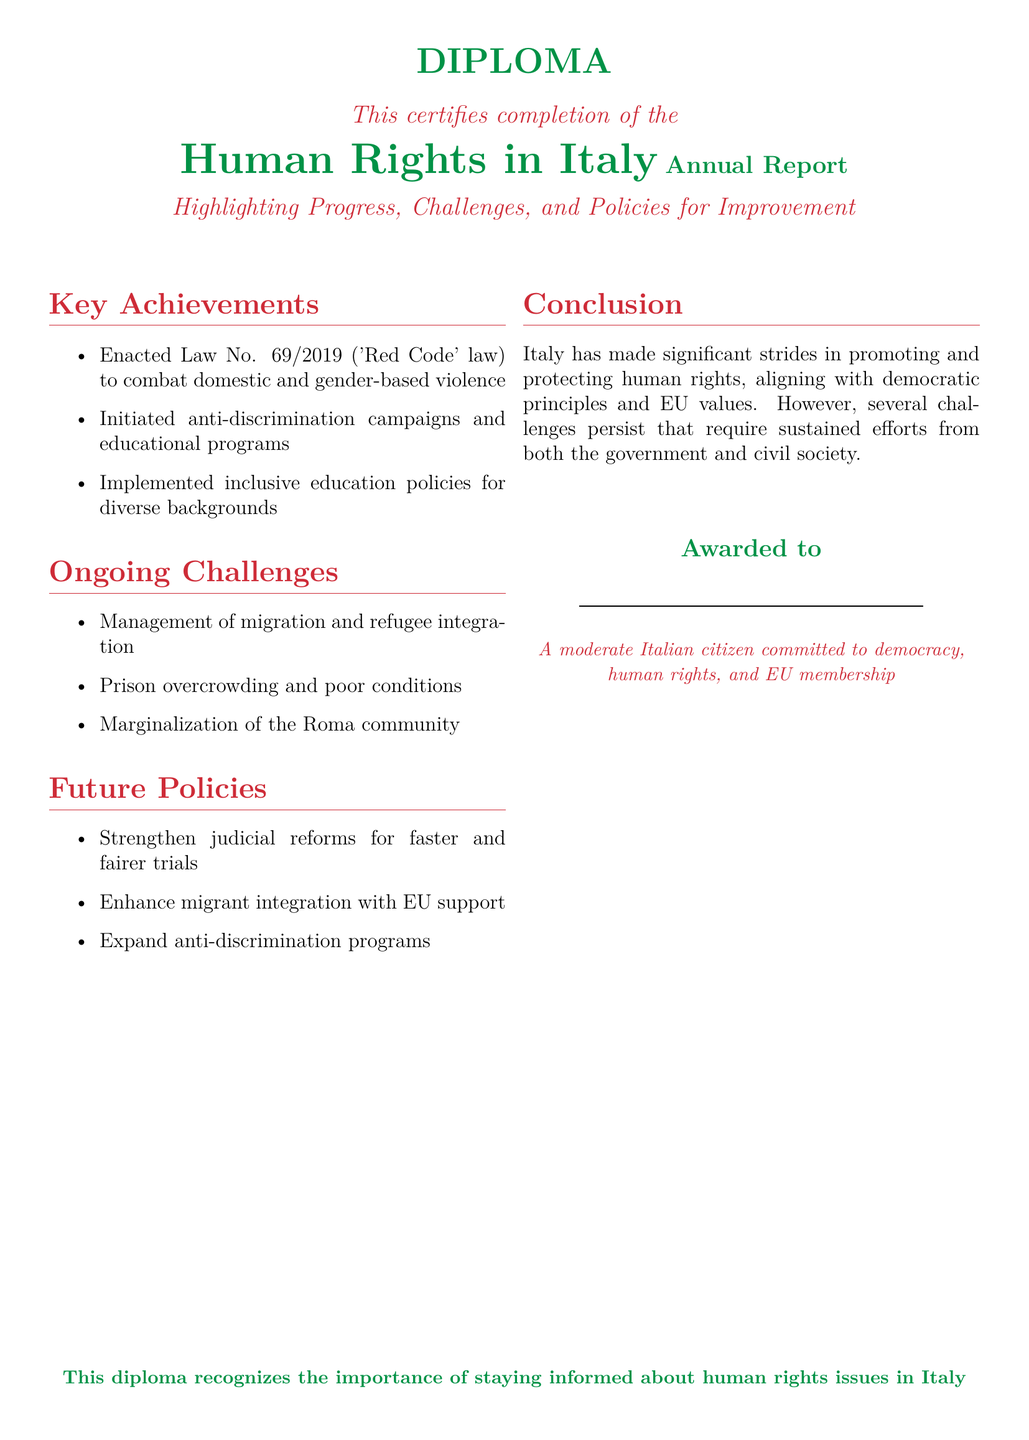What is the title of the diploma? The title of the diploma is prominently displayed at the top of the document, stating "Human Rights in Italy Annual Report."
Answer: Human Rights in Italy Annual Report What year was the 'Red Code' law enacted? The document mentions that the 'Red Code' law was enacted under Law No. 69/2019.
Answer: 2019 What is one ongoing challenge mentioned in the report? The document lists several ongoing challenges; one of them is "Management of migration and refugee integration."
Answer: Management of migration and refugee integration Which community is mentioned as being marginalized? The document explicitly mentions the "Roma community" as marginalized.
Answer: Roma community What is one future policy proposed in the report? The report outlines several future policies; one proposed policy is "Strengthen judicial reforms for faster and fairer trials."
Answer: Strengthen judicial reforms for faster and fairer trials What color is used for the heading in the Key Achievements section? The color used for the heading in the Key Achievements section is identified as "italyred."
Answer: italyred Who is the diploma awarded to? The diploma mentions it is awarded to "A moderate Italian citizen committed to democracy, human rights, and EU membership."
Answer: A moderate Italian citizen committed to democracy, human rights, and EU membership What is the conclusion about Italy's progress in human rights? The conclusion states that Italy has made significant strides in promoting and protecting human rights.
Answer: Significant strides in promoting and protecting human rights 